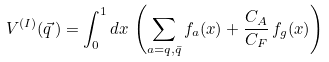<formula> <loc_0><loc_0><loc_500><loc_500>V ^ { ( I ) } ( \vec { q } \, ) = \int _ { 0 } ^ { 1 } d x \, \left ( \sum _ { a = q , \bar { q } } f _ { a } ( x ) + \frac { C _ { A } } { C _ { F } } \, f _ { g } ( x ) \right )</formula> 